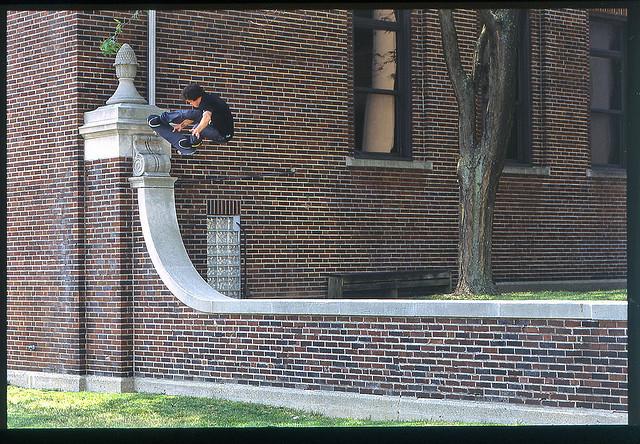How many children do you see?
Concise answer only. 1. What is the boy doing?
Give a very brief answer. Skateboarding. What is the building made of?
Quick response, please. Brick. 